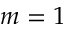Convert formula to latex. <formula><loc_0><loc_0><loc_500><loc_500>m = 1</formula> 